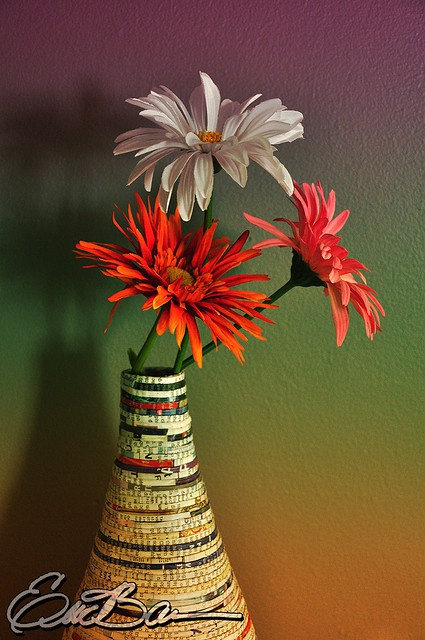Describe the objects in this image and their specific colors. I can see a vase in purple, black, olive, and khaki tones in this image. 